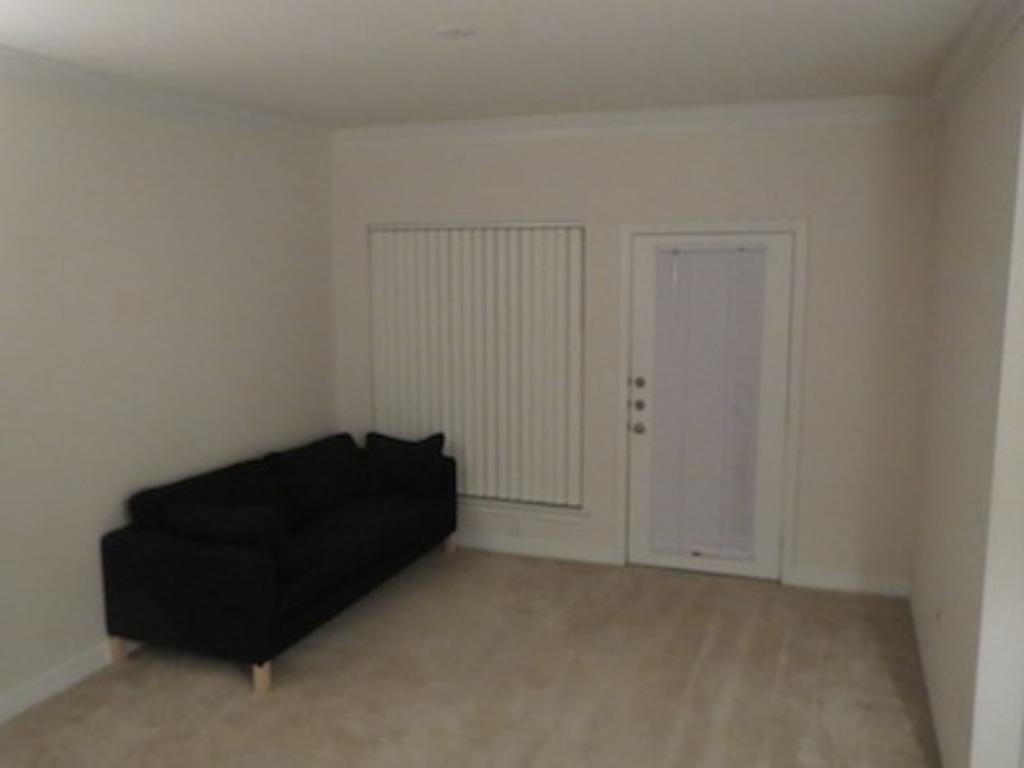What type of furniture is in the room? There is a sofa in the room. Where is the sofa located in the room? The sofa is located in a corner. What color is the sofa? The color of the sofa is black. What are the two architectural features in the room? There is a door and a window in the room. How many snails can be seen crawling on the sofa in the image? There are no snails present in the image; the sofa is black and located in a corner. 